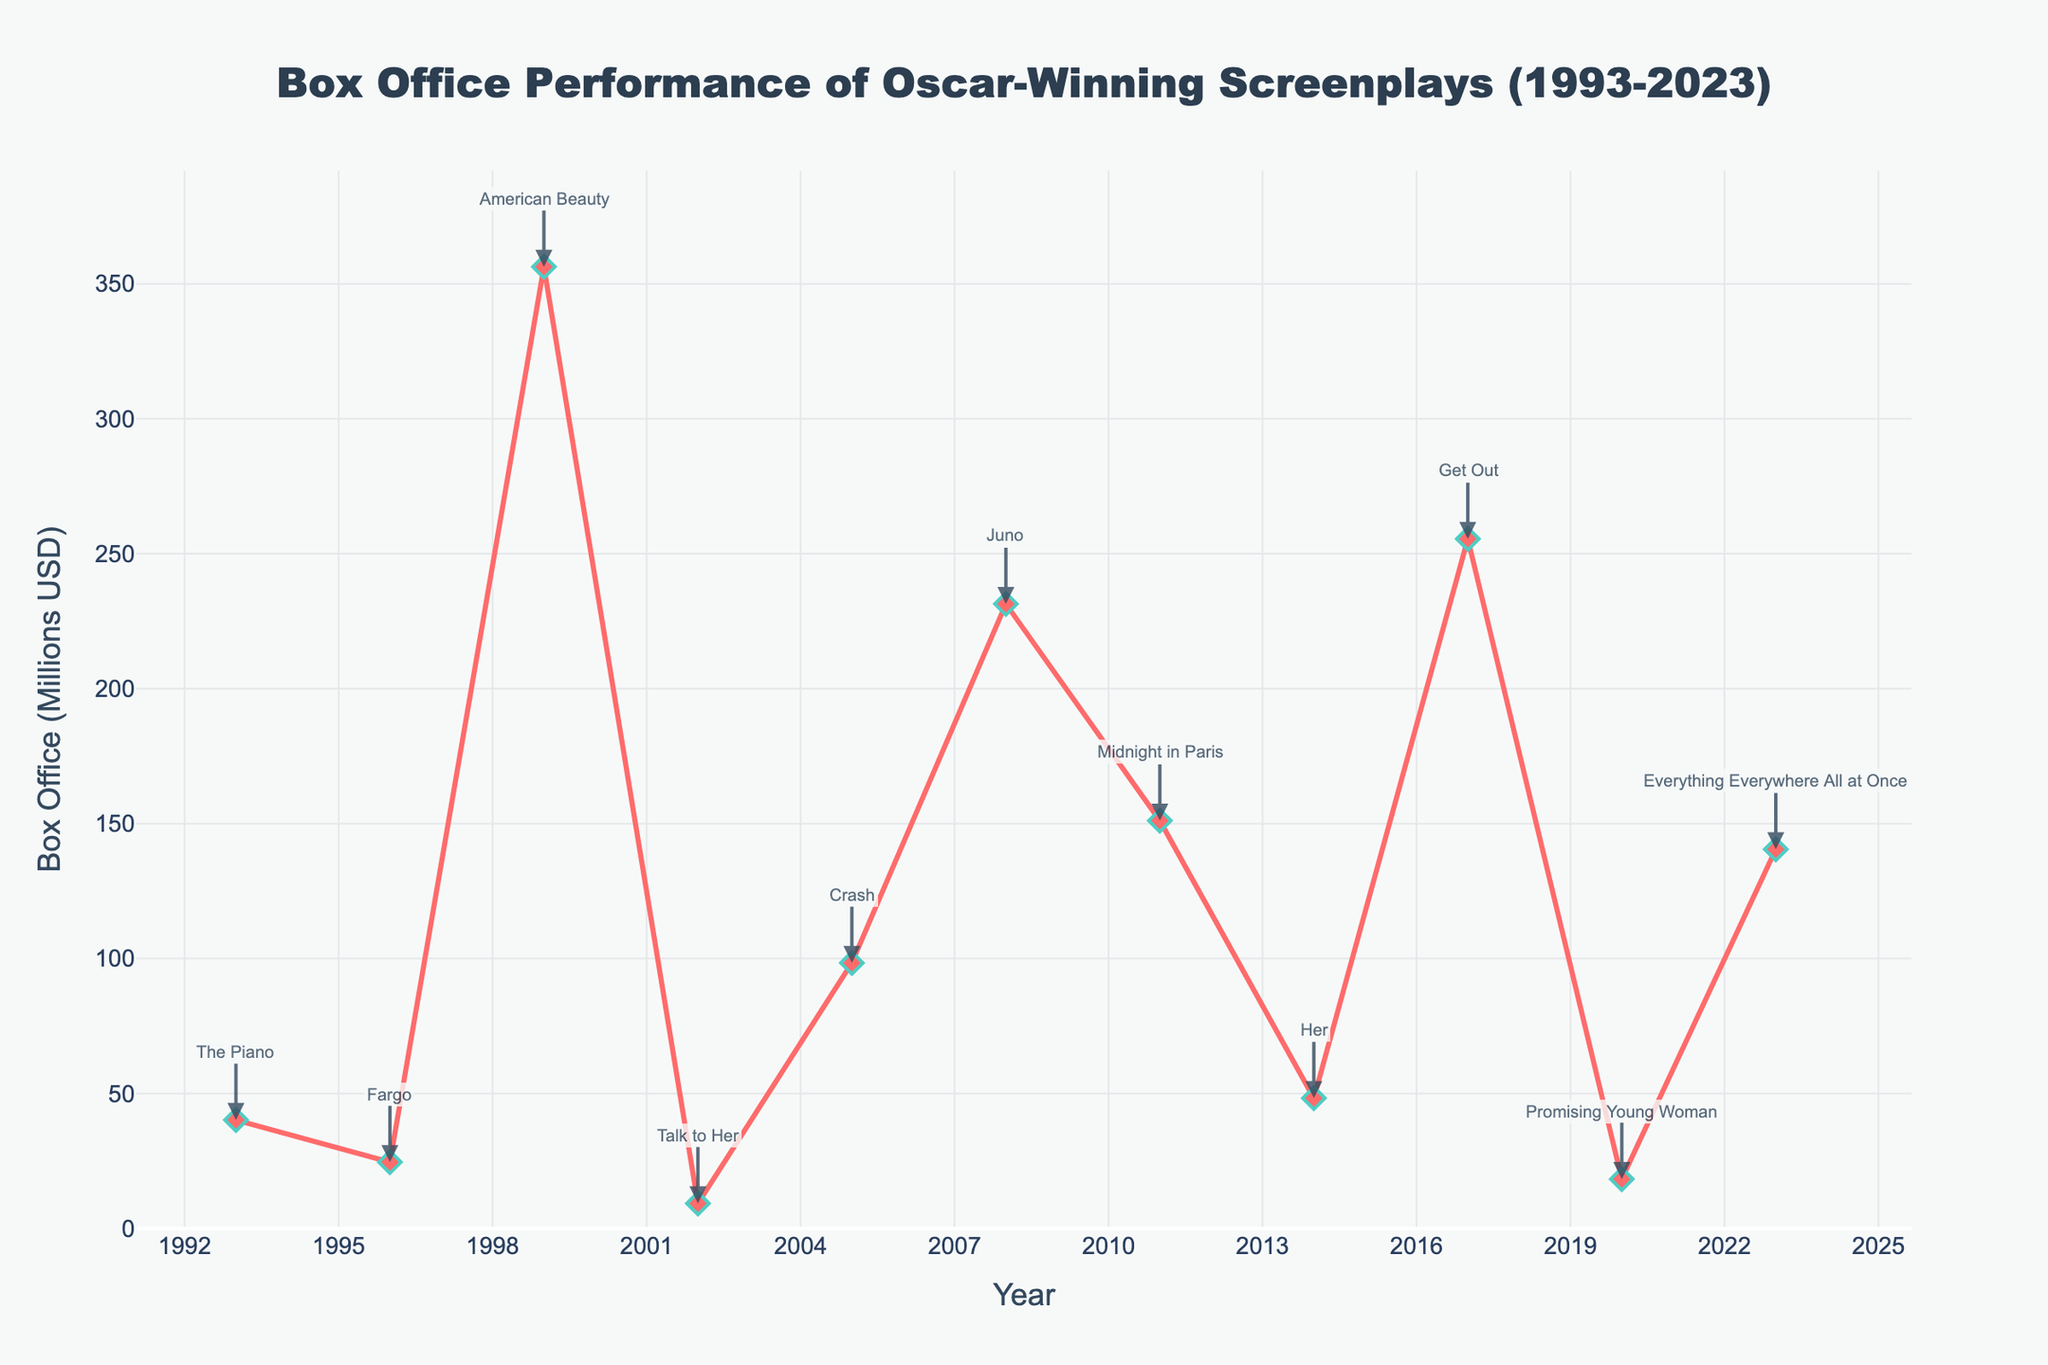Which film had the highest box office performance? According to the figure, "American Beauty" had the highest box office performance among the Oscar-winning screenplays between 1993 and 2023.
Answer: American Beauty What is the difference in box office performance between "The Piano" and "Get Out"? "The Piano" had a box office performance of 40.2 million USD, and "Get Out" had 255.5 million USD. Subtracting these gives: 255.5 - 40.2 = 215.3 million USD.
Answer: 215.3 million USD Which year had the lowest box office performance? By observing the figure, "Talk to Her" in 2002 had the lowest box office performance at 9.3 million USD.
Answer: 2002 How many films had a box office performance above 200 million USD? The films that had a box office performance above 200 million USD are: "American Beauty" (356.3), "Juno" (231.4), and "Get Out" (255.5). Counting these, we get 3 films.
Answer: 3 What is the average box office performance for films between 1993 and 2023? Sum all the box office performances and divide by the number of films: (40.2 + 24.6 + 356.3 + 9.3 + 98.4 + 231.4 + 151.1 + 48.3 + 255.5 + 18.3 + 140.5) / 11. The total is 1374.9 million USD, and the average is 1374.9 / 11.
Answer: 124.99 million USD Which film had the second highest box office performance? From the figure, after "American Beauty" (356.3 million USD), the next highest box office performance is "Get Out" (255.5 million USD).
Answer: Get Out How much did "Promising Young Woman" earn compared to "Fargo"? "Promising Young Woman" earned 18.3 million USD, and "Fargo" earned 24.6 million USD. Subtracting these gives: 24.6 - 18.3 = 6.3 million USD less.
Answer: 6.3 million USD less List all films with box office performance under 50 million USD. From the figure, the films with box office performance under 50 million USD are "Fargo" (24.6), "Talk to Her" (9.3), "Promising Young Woman" (18.3), and "Her" (48.3).
Answer: Fargo, Talk to Her, Promising Young Woman, Her What is the trend of box office performance over the years? Observing the figure, the box office performance does not show a consistent upward or downward trend. It fluctuates significantly over the years with peaks in certain periods like in 1999 ("American Beauty") and 2017 ("Get Out").
Answer: Fluctuating What is the combined box office performance of films in the 2000s (2000-2009)? The films released in the 2000s are "Talk to Her" (2002) with 9.3 million USD, "Crash" (2005) with 98.4 million USD, and "Juno" (2008) with 231.4 million USD. Adding these gives: 9.3 + 98.4 + 231.4 = 339.1 million USD.
Answer: 339.1 million USD 